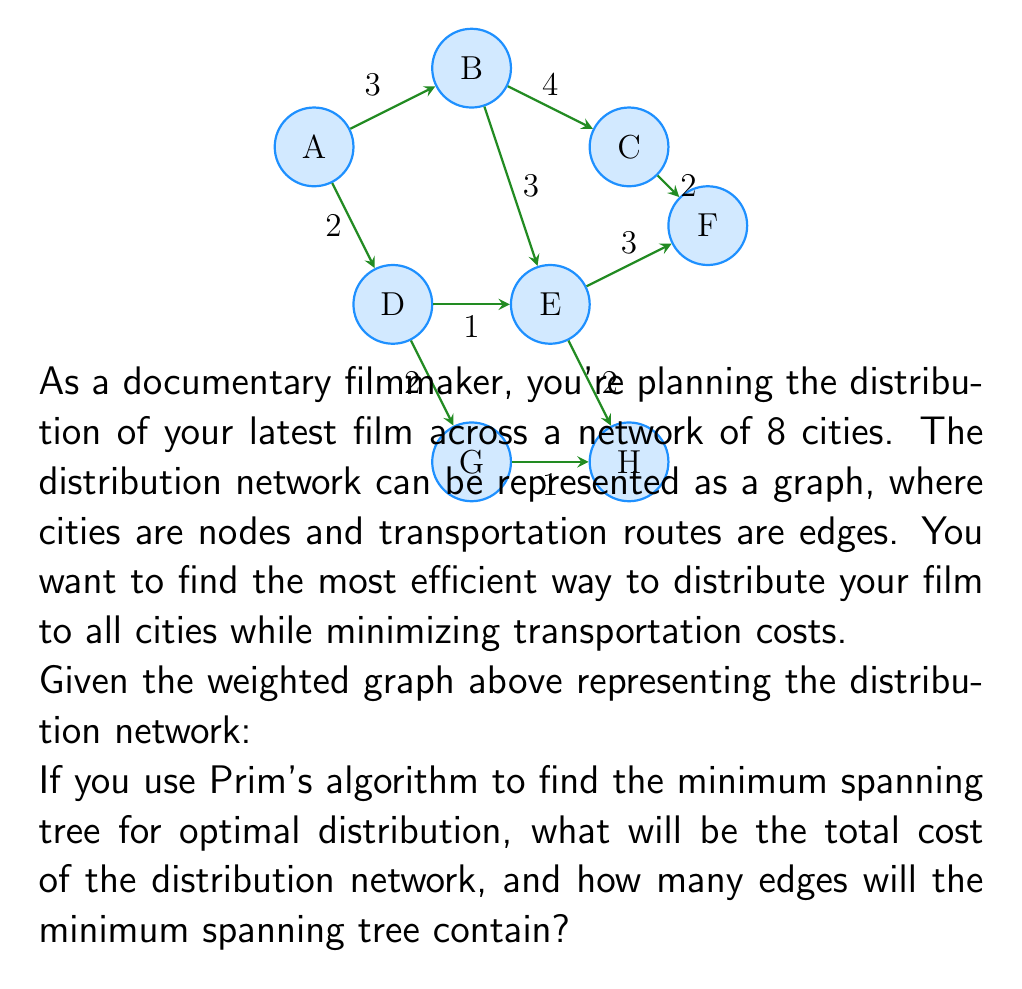Can you solve this math problem? Let's solve this problem step by step using Prim's algorithm:

1) Prim's algorithm starts with an arbitrary vertex and grows the minimum spanning tree (MST) by adding the cheapest edge that connects a vertex in the MST to a vertex not yet in the MST.

2) Let's start with vertex A:
   - Add edge A-D with weight 2
   - MST: {A-D}, Cost: 2

3) From vertices A and D, the cheapest edge to a new vertex is D-E with weight 1:
   - Add edge D-E
   - MST: {A-D, D-E}, Cost: 2 + 1 = 3

4) The cheapest edge to a new vertex is now E-H with weight 2:
   - Add edge E-H
   - MST: {A-D, D-E, E-H}, Cost: 3 + 2 = 5

5) The cheapest edge to a new vertex is D-G with weight 2:
   - Add edge D-G
   - MST: {A-D, D-E, E-H, D-G}, Cost: 5 + 2 = 7

6) The cheapest edge to a new vertex is A-B with weight 3:
   - Add edge A-B
   - MST: {A-D, D-E, E-H, D-G, A-B}, Cost: 7 + 3 = 10

7) The cheapest edge to a new vertex is E-F with weight 3:
   - Add edge E-F
   - MST: {A-D, D-E, E-H, D-G, A-B, E-F}, Cost: 10 + 3 = 13

8) The last vertex to add is C, and the cheapest edge to it is B-C with weight 4:
   - Add edge B-C
   - MST: {A-D, D-E, E-H, D-G, A-B, E-F, B-C}, Cost: 13 + 4 = 17

The algorithm terminates as all vertices are now included in the MST.

The total cost of the distribution network is 17.

For a graph with $n$ vertices, a spanning tree always has $n-1$ edges. In this case, with 8 vertices, the minimum spanning tree contains 7 edges.
Answer: Total cost: 17; Number of edges: 7 